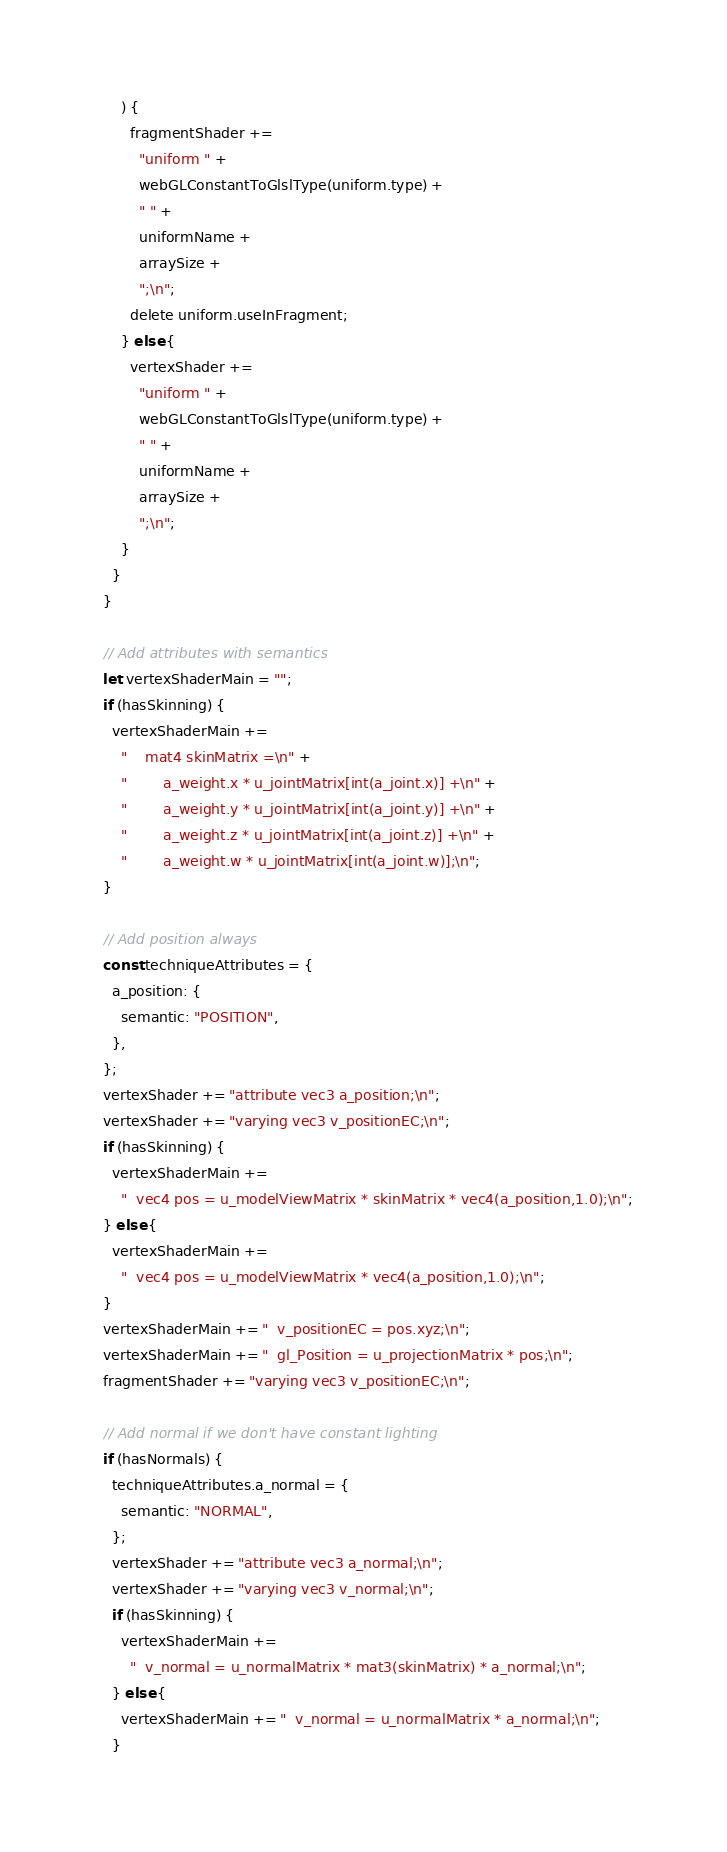<code> <loc_0><loc_0><loc_500><loc_500><_JavaScript_>      ) {
        fragmentShader +=
          "uniform " +
          webGLConstantToGlslType(uniform.type) +
          " " +
          uniformName +
          arraySize +
          ";\n";
        delete uniform.useInFragment;
      } else {
        vertexShader +=
          "uniform " +
          webGLConstantToGlslType(uniform.type) +
          " " +
          uniformName +
          arraySize +
          ";\n";
      }
    }
  }

  // Add attributes with semantics
  let vertexShaderMain = "";
  if (hasSkinning) {
    vertexShaderMain +=
      "    mat4 skinMatrix =\n" +
      "        a_weight.x * u_jointMatrix[int(a_joint.x)] +\n" +
      "        a_weight.y * u_jointMatrix[int(a_joint.y)] +\n" +
      "        a_weight.z * u_jointMatrix[int(a_joint.z)] +\n" +
      "        a_weight.w * u_jointMatrix[int(a_joint.w)];\n";
  }

  // Add position always
  const techniqueAttributes = {
    a_position: {
      semantic: "POSITION",
    },
  };
  vertexShader += "attribute vec3 a_position;\n";
  vertexShader += "varying vec3 v_positionEC;\n";
  if (hasSkinning) {
    vertexShaderMain +=
      "  vec4 pos = u_modelViewMatrix * skinMatrix * vec4(a_position,1.0);\n";
  } else {
    vertexShaderMain +=
      "  vec4 pos = u_modelViewMatrix * vec4(a_position,1.0);\n";
  }
  vertexShaderMain += "  v_positionEC = pos.xyz;\n";
  vertexShaderMain += "  gl_Position = u_projectionMatrix * pos;\n";
  fragmentShader += "varying vec3 v_positionEC;\n";

  // Add normal if we don't have constant lighting
  if (hasNormals) {
    techniqueAttributes.a_normal = {
      semantic: "NORMAL",
    };
    vertexShader += "attribute vec3 a_normal;\n";
    vertexShader += "varying vec3 v_normal;\n";
    if (hasSkinning) {
      vertexShaderMain +=
        "  v_normal = u_normalMatrix * mat3(skinMatrix) * a_normal;\n";
    } else {
      vertexShaderMain += "  v_normal = u_normalMatrix * a_normal;\n";
    }
</code> 